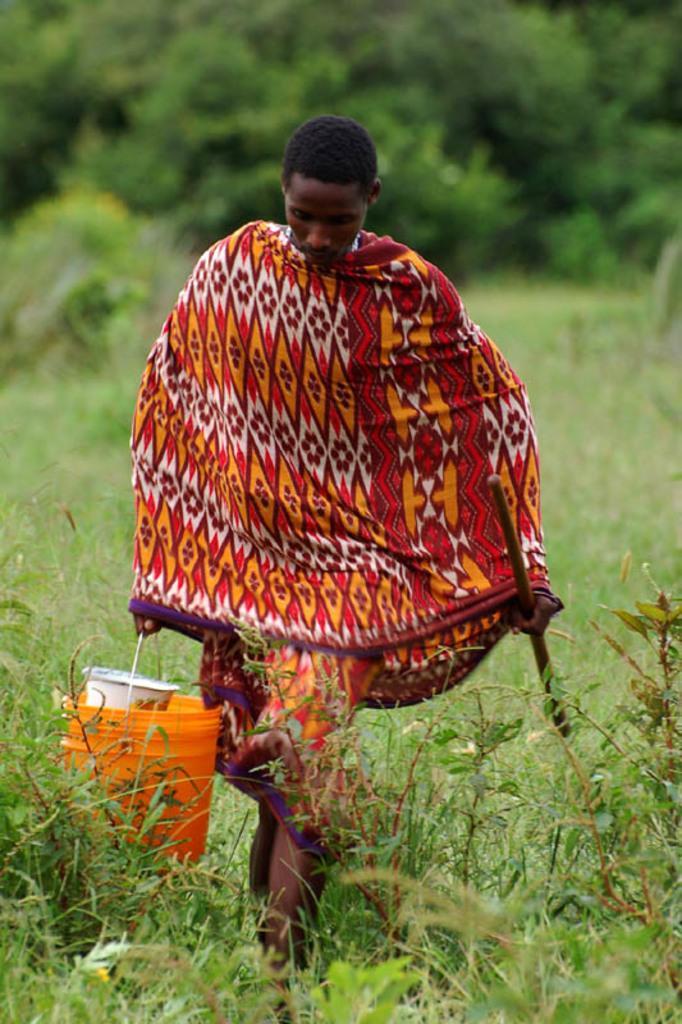Can you describe this image briefly? In this picture I can see a man holding a stick with one hand and a bucket in another hand and I can see grass and plants on the ground and I can see trees in the back. 